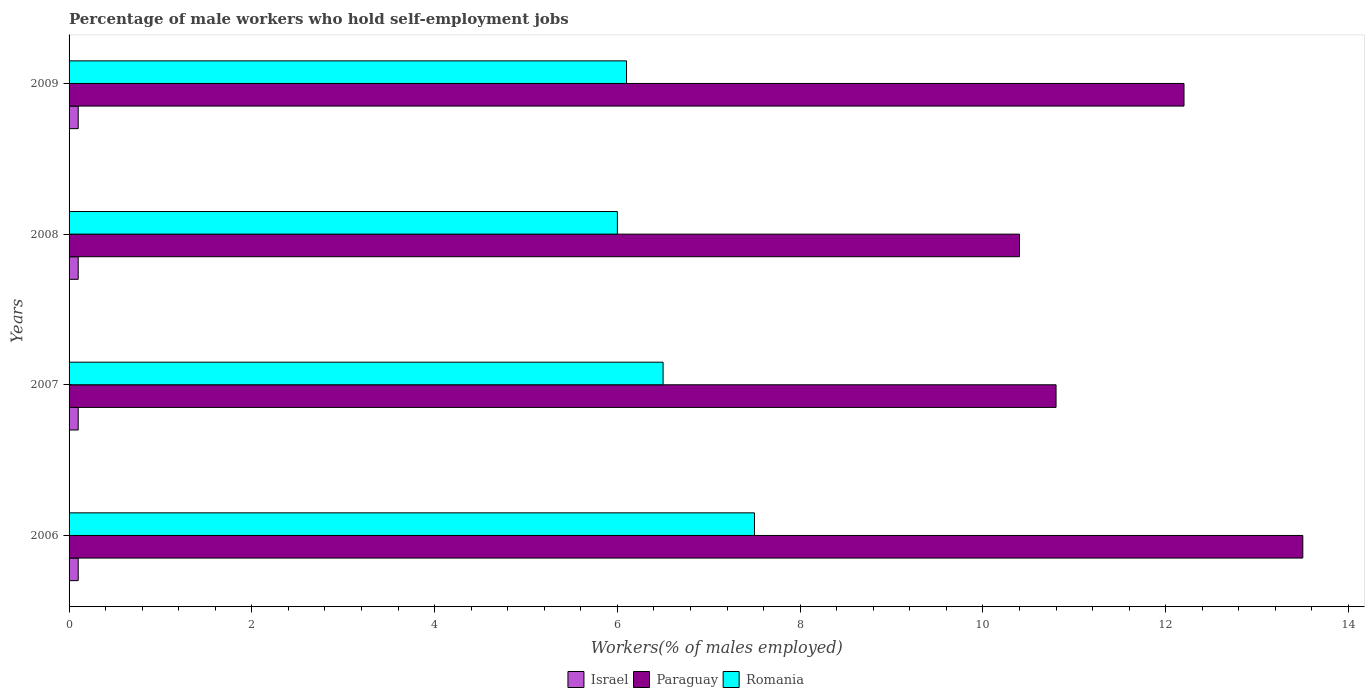Are the number of bars on each tick of the Y-axis equal?
Offer a terse response. Yes. How many bars are there on the 3rd tick from the top?
Offer a very short reply. 3. What is the label of the 1st group of bars from the top?
Make the answer very short. 2009. In how many cases, is the number of bars for a given year not equal to the number of legend labels?
Offer a very short reply. 0. What is the percentage of self-employed male workers in Israel in 2006?
Offer a very short reply. 0.1. Across all years, what is the maximum percentage of self-employed male workers in Romania?
Your answer should be very brief. 7.5. Across all years, what is the minimum percentage of self-employed male workers in Israel?
Your answer should be compact. 0.1. In which year was the percentage of self-employed male workers in Paraguay maximum?
Offer a terse response. 2006. What is the total percentage of self-employed male workers in Israel in the graph?
Your answer should be very brief. 0.4. What is the difference between the percentage of self-employed male workers in Paraguay in 2007 and that in 2009?
Offer a terse response. -1.4. What is the difference between the percentage of self-employed male workers in Israel in 2006 and the percentage of self-employed male workers in Paraguay in 2009?
Your answer should be very brief. -12.1. What is the average percentage of self-employed male workers in Israel per year?
Provide a succinct answer. 0.1. In the year 2009, what is the difference between the percentage of self-employed male workers in Paraguay and percentage of self-employed male workers in Romania?
Offer a terse response. 6.1. What is the ratio of the percentage of self-employed male workers in Romania in 2006 to that in 2007?
Your answer should be compact. 1.15. Is the percentage of self-employed male workers in Romania in 2008 less than that in 2009?
Ensure brevity in your answer.  Yes. Is the difference between the percentage of self-employed male workers in Paraguay in 2007 and 2008 greater than the difference between the percentage of self-employed male workers in Romania in 2007 and 2008?
Give a very brief answer. No. What is the difference between the highest and the lowest percentage of self-employed male workers in Romania?
Keep it short and to the point. 1.5. In how many years, is the percentage of self-employed male workers in Israel greater than the average percentage of self-employed male workers in Israel taken over all years?
Ensure brevity in your answer.  0. Is the sum of the percentage of self-employed male workers in Romania in 2006 and 2007 greater than the maximum percentage of self-employed male workers in Paraguay across all years?
Ensure brevity in your answer.  Yes. What does the 2nd bar from the bottom in 2007 represents?
Provide a short and direct response. Paraguay. How many bars are there?
Provide a succinct answer. 12. What is the difference between two consecutive major ticks on the X-axis?
Keep it short and to the point. 2. How are the legend labels stacked?
Make the answer very short. Horizontal. What is the title of the graph?
Your answer should be very brief. Percentage of male workers who hold self-employment jobs. Does "Oman" appear as one of the legend labels in the graph?
Offer a very short reply. No. What is the label or title of the X-axis?
Offer a very short reply. Workers(% of males employed). What is the label or title of the Y-axis?
Provide a succinct answer. Years. What is the Workers(% of males employed) of Israel in 2006?
Your answer should be very brief. 0.1. What is the Workers(% of males employed) of Paraguay in 2006?
Your answer should be very brief. 13.5. What is the Workers(% of males employed) of Israel in 2007?
Provide a succinct answer. 0.1. What is the Workers(% of males employed) of Paraguay in 2007?
Keep it short and to the point. 10.8. What is the Workers(% of males employed) in Romania in 2007?
Offer a terse response. 6.5. What is the Workers(% of males employed) in Israel in 2008?
Make the answer very short. 0.1. What is the Workers(% of males employed) in Paraguay in 2008?
Provide a succinct answer. 10.4. What is the Workers(% of males employed) of Israel in 2009?
Provide a succinct answer. 0.1. What is the Workers(% of males employed) in Paraguay in 2009?
Your answer should be very brief. 12.2. What is the Workers(% of males employed) of Romania in 2009?
Keep it short and to the point. 6.1. Across all years, what is the maximum Workers(% of males employed) in Israel?
Your answer should be compact. 0.1. Across all years, what is the maximum Workers(% of males employed) of Paraguay?
Ensure brevity in your answer.  13.5. Across all years, what is the minimum Workers(% of males employed) of Israel?
Your answer should be compact. 0.1. Across all years, what is the minimum Workers(% of males employed) in Paraguay?
Your response must be concise. 10.4. What is the total Workers(% of males employed) in Paraguay in the graph?
Provide a succinct answer. 46.9. What is the total Workers(% of males employed) of Romania in the graph?
Provide a short and direct response. 26.1. What is the difference between the Workers(% of males employed) of Israel in 2006 and that in 2007?
Keep it short and to the point. 0. What is the difference between the Workers(% of males employed) in Israel in 2006 and that in 2009?
Your answer should be compact. 0. What is the difference between the Workers(% of males employed) in Paraguay in 2007 and that in 2008?
Give a very brief answer. 0.4. What is the difference between the Workers(% of males employed) of Romania in 2007 and that in 2009?
Offer a terse response. 0.4. What is the difference between the Workers(% of males employed) in Israel in 2008 and that in 2009?
Your answer should be compact. 0. What is the difference between the Workers(% of males employed) in Paraguay in 2008 and that in 2009?
Offer a terse response. -1.8. What is the difference between the Workers(% of males employed) of Israel in 2006 and the Workers(% of males employed) of Romania in 2007?
Your answer should be very brief. -6.4. What is the difference between the Workers(% of males employed) in Paraguay in 2006 and the Workers(% of males employed) in Romania in 2007?
Ensure brevity in your answer.  7. What is the difference between the Workers(% of males employed) of Israel in 2006 and the Workers(% of males employed) of Paraguay in 2008?
Make the answer very short. -10.3. What is the difference between the Workers(% of males employed) in Paraguay in 2006 and the Workers(% of males employed) in Romania in 2008?
Give a very brief answer. 7.5. What is the difference between the Workers(% of males employed) in Israel in 2006 and the Workers(% of males employed) in Paraguay in 2009?
Provide a short and direct response. -12.1. What is the difference between the Workers(% of males employed) in Israel in 2007 and the Workers(% of males employed) in Paraguay in 2008?
Ensure brevity in your answer.  -10.3. What is the difference between the Workers(% of males employed) of Israel in 2007 and the Workers(% of males employed) of Romania in 2008?
Offer a terse response. -5.9. What is the difference between the Workers(% of males employed) of Paraguay in 2007 and the Workers(% of males employed) of Romania in 2008?
Make the answer very short. 4.8. What is the difference between the Workers(% of males employed) of Israel in 2007 and the Workers(% of males employed) of Paraguay in 2009?
Provide a succinct answer. -12.1. What is the difference between the Workers(% of males employed) in Israel in 2008 and the Workers(% of males employed) in Paraguay in 2009?
Give a very brief answer. -12.1. What is the difference between the Workers(% of males employed) of Paraguay in 2008 and the Workers(% of males employed) of Romania in 2009?
Ensure brevity in your answer.  4.3. What is the average Workers(% of males employed) of Israel per year?
Make the answer very short. 0.1. What is the average Workers(% of males employed) of Paraguay per year?
Provide a succinct answer. 11.72. What is the average Workers(% of males employed) in Romania per year?
Provide a succinct answer. 6.53. In the year 2006, what is the difference between the Workers(% of males employed) in Israel and Workers(% of males employed) in Romania?
Keep it short and to the point. -7.4. In the year 2007, what is the difference between the Workers(% of males employed) of Israel and Workers(% of males employed) of Paraguay?
Your response must be concise. -10.7. What is the ratio of the Workers(% of males employed) in Paraguay in 2006 to that in 2007?
Give a very brief answer. 1.25. What is the ratio of the Workers(% of males employed) in Romania in 2006 to that in 2007?
Provide a short and direct response. 1.15. What is the ratio of the Workers(% of males employed) in Paraguay in 2006 to that in 2008?
Keep it short and to the point. 1.3. What is the ratio of the Workers(% of males employed) in Israel in 2006 to that in 2009?
Your response must be concise. 1. What is the ratio of the Workers(% of males employed) of Paraguay in 2006 to that in 2009?
Provide a short and direct response. 1.11. What is the ratio of the Workers(% of males employed) in Romania in 2006 to that in 2009?
Make the answer very short. 1.23. What is the ratio of the Workers(% of males employed) in Paraguay in 2007 to that in 2008?
Give a very brief answer. 1.04. What is the ratio of the Workers(% of males employed) in Israel in 2007 to that in 2009?
Your answer should be compact. 1. What is the ratio of the Workers(% of males employed) of Paraguay in 2007 to that in 2009?
Your answer should be very brief. 0.89. What is the ratio of the Workers(% of males employed) of Romania in 2007 to that in 2009?
Make the answer very short. 1.07. What is the ratio of the Workers(% of males employed) in Paraguay in 2008 to that in 2009?
Keep it short and to the point. 0.85. What is the ratio of the Workers(% of males employed) of Romania in 2008 to that in 2009?
Provide a short and direct response. 0.98. What is the difference between the highest and the second highest Workers(% of males employed) of Paraguay?
Make the answer very short. 1.3. What is the difference between the highest and the lowest Workers(% of males employed) of Israel?
Your answer should be very brief. 0. 